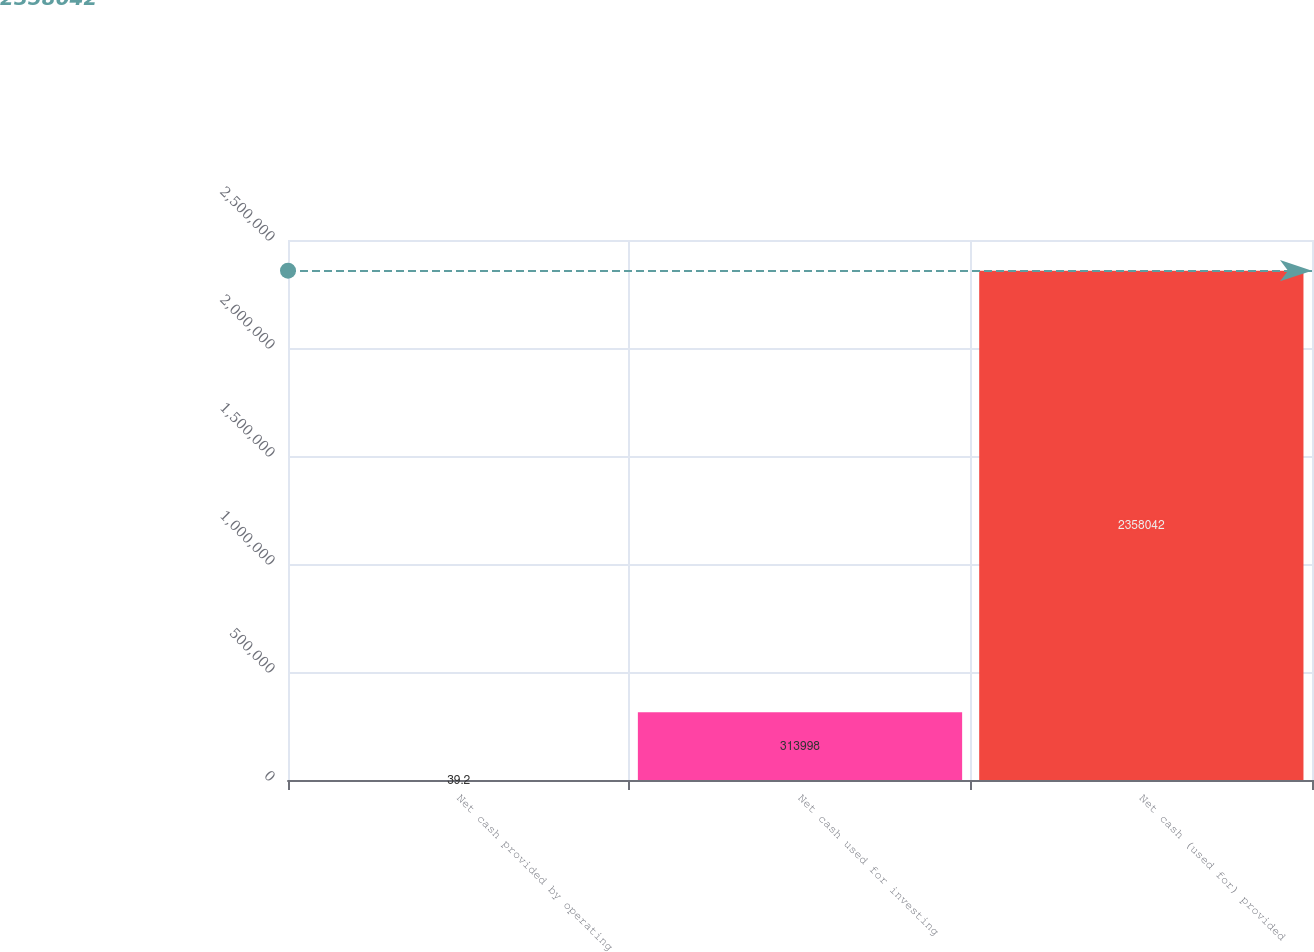Convert chart to OTSL. <chart><loc_0><loc_0><loc_500><loc_500><bar_chart><fcel>Net cash provided by operating<fcel>Net cash used for investing<fcel>Net cash (used for) provided<nl><fcel>39.2<fcel>313998<fcel>2.35804e+06<nl></chart> 